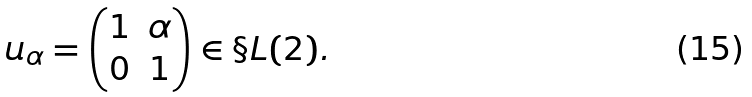Convert formula to latex. <formula><loc_0><loc_0><loc_500><loc_500>u _ { \alpha } = \begin{pmatrix} 1 & \alpha \\ 0 & 1 \end{pmatrix} \in \S L ( 2 ) .</formula> 